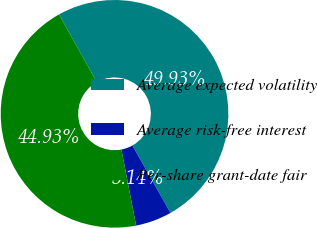<chart> <loc_0><loc_0><loc_500><loc_500><pie_chart><fcel>Average expected volatility<fcel>Average risk-free interest<fcel>Per-share grant-date fair<nl><fcel>49.93%<fcel>5.14%<fcel>44.93%<nl></chart> 